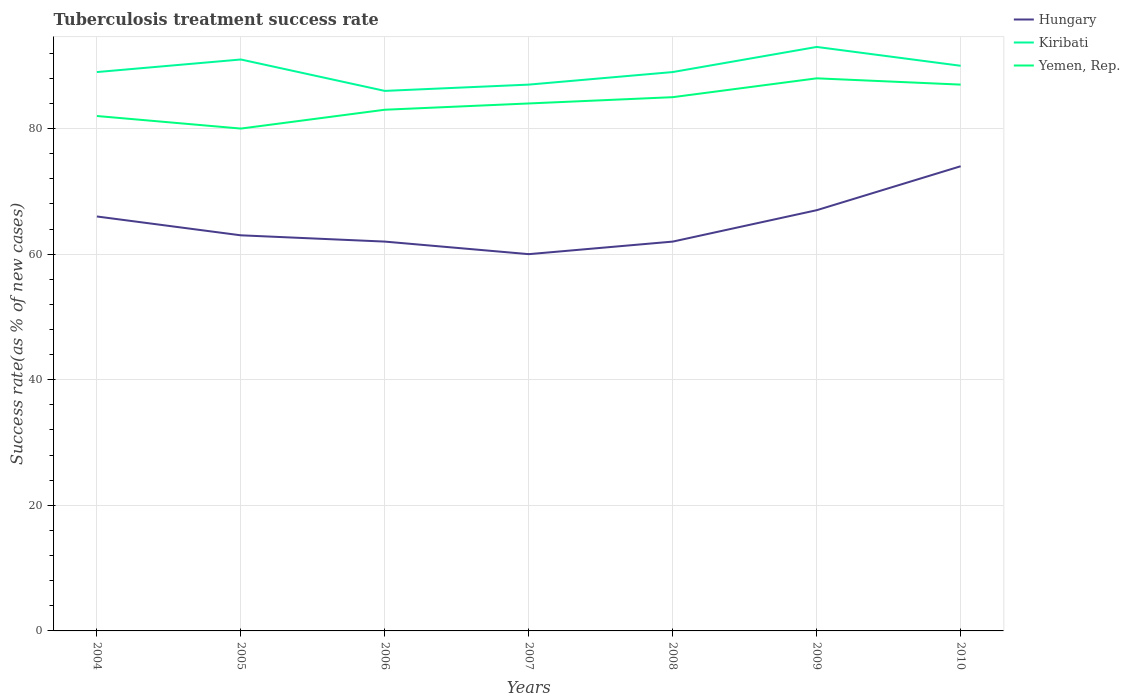How many different coloured lines are there?
Offer a terse response. 3. Across all years, what is the maximum tuberculosis treatment success rate in Yemen, Rep.?
Keep it short and to the point. 80. What is the total tuberculosis treatment success rate in Hungary in the graph?
Your answer should be compact. 4. What is the difference between the highest and the second highest tuberculosis treatment success rate in Kiribati?
Offer a terse response. 7. What is the difference between the highest and the lowest tuberculosis treatment success rate in Hungary?
Provide a succinct answer. 3. How many lines are there?
Keep it short and to the point. 3. How many years are there in the graph?
Offer a terse response. 7. Are the values on the major ticks of Y-axis written in scientific E-notation?
Ensure brevity in your answer.  No. Does the graph contain grids?
Provide a succinct answer. Yes. How are the legend labels stacked?
Offer a very short reply. Vertical. What is the title of the graph?
Your response must be concise. Tuberculosis treatment success rate. What is the label or title of the Y-axis?
Offer a very short reply. Success rate(as % of new cases). What is the Success rate(as % of new cases) of Kiribati in 2004?
Offer a terse response. 89. What is the Success rate(as % of new cases) in Hungary in 2005?
Your answer should be very brief. 63. What is the Success rate(as % of new cases) of Kiribati in 2005?
Provide a succinct answer. 91. What is the Success rate(as % of new cases) in Kiribati in 2006?
Your response must be concise. 86. What is the Success rate(as % of new cases) of Kiribati in 2007?
Offer a very short reply. 87. What is the Success rate(as % of new cases) in Yemen, Rep. in 2007?
Your answer should be very brief. 84. What is the Success rate(as % of new cases) of Kiribati in 2008?
Ensure brevity in your answer.  89. What is the Success rate(as % of new cases) in Kiribati in 2009?
Provide a short and direct response. 93. What is the Success rate(as % of new cases) of Hungary in 2010?
Make the answer very short. 74. What is the Success rate(as % of new cases) in Kiribati in 2010?
Your answer should be very brief. 90. What is the Success rate(as % of new cases) of Yemen, Rep. in 2010?
Provide a short and direct response. 87. Across all years, what is the maximum Success rate(as % of new cases) in Hungary?
Provide a succinct answer. 74. Across all years, what is the maximum Success rate(as % of new cases) in Kiribati?
Your response must be concise. 93. Across all years, what is the minimum Success rate(as % of new cases) in Hungary?
Offer a terse response. 60. What is the total Success rate(as % of new cases) in Hungary in the graph?
Your answer should be compact. 454. What is the total Success rate(as % of new cases) of Kiribati in the graph?
Provide a succinct answer. 625. What is the total Success rate(as % of new cases) of Yemen, Rep. in the graph?
Provide a succinct answer. 589. What is the difference between the Success rate(as % of new cases) in Kiribati in 2004 and that in 2005?
Give a very brief answer. -2. What is the difference between the Success rate(as % of new cases) in Yemen, Rep. in 2004 and that in 2005?
Make the answer very short. 2. What is the difference between the Success rate(as % of new cases) of Kiribati in 2004 and that in 2006?
Provide a succinct answer. 3. What is the difference between the Success rate(as % of new cases) in Hungary in 2004 and that in 2007?
Your answer should be very brief. 6. What is the difference between the Success rate(as % of new cases) of Kiribati in 2004 and that in 2007?
Provide a succinct answer. 2. What is the difference between the Success rate(as % of new cases) in Yemen, Rep. in 2004 and that in 2007?
Offer a very short reply. -2. What is the difference between the Success rate(as % of new cases) of Hungary in 2004 and that in 2009?
Provide a short and direct response. -1. What is the difference between the Success rate(as % of new cases) in Hungary in 2004 and that in 2010?
Your response must be concise. -8. What is the difference between the Success rate(as % of new cases) in Yemen, Rep. in 2004 and that in 2010?
Your answer should be very brief. -5. What is the difference between the Success rate(as % of new cases) of Kiribati in 2005 and that in 2006?
Offer a very short reply. 5. What is the difference between the Success rate(as % of new cases) of Yemen, Rep. in 2005 and that in 2006?
Provide a succinct answer. -3. What is the difference between the Success rate(as % of new cases) in Kiribati in 2005 and that in 2007?
Your answer should be compact. 4. What is the difference between the Success rate(as % of new cases) of Yemen, Rep. in 2005 and that in 2007?
Give a very brief answer. -4. What is the difference between the Success rate(as % of new cases) of Hungary in 2005 and that in 2008?
Offer a terse response. 1. What is the difference between the Success rate(as % of new cases) of Kiribati in 2005 and that in 2008?
Offer a terse response. 2. What is the difference between the Success rate(as % of new cases) in Kiribati in 2005 and that in 2009?
Your answer should be very brief. -2. What is the difference between the Success rate(as % of new cases) of Yemen, Rep. in 2005 and that in 2009?
Keep it short and to the point. -8. What is the difference between the Success rate(as % of new cases) of Kiribati in 2005 and that in 2010?
Your answer should be very brief. 1. What is the difference between the Success rate(as % of new cases) in Yemen, Rep. in 2005 and that in 2010?
Offer a terse response. -7. What is the difference between the Success rate(as % of new cases) of Hungary in 2006 and that in 2007?
Your answer should be very brief. 2. What is the difference between the Success rate(as % of new cases) in Kiribati in 2006 and that in 2007?
Offer a terse response. -1. What is the difference between the Success rate(as % of new cases) of Hungary in 2006 and that in 2008?
Offer a very short reply. 0. What is the difference between the Success rate(as % of new cases) of Kiribati in 2006 and that in 2008?
Offer a very short reply. -3. What is the difference between the Success rate(as % of new cases) of Hungary in 2006 and that in 2009?
Provide a short and direct response. -5. What is the difference between the Success rate(as % of new cases) in Kiribati in 2006 and that in 2009?
Your answer should be compact. -7. What is the difference between the Success rate(as % of new cases) in Yemen, Rep. in 2006 and that in 2010?
Make the answer very short. -4. What is the difference between the Success rate(as % of new cases) in Hungary in 2007 and that in 2008?
Your response must be concise. -2. What is the difference between the Success rate(as % of new cases) in Kiribati in 2007 and that in 2008?
Make the answer very short. -2. What is the difference between the Success rate(as % of new cases) in Yemen, Rep. in 2007 and that in 2008?
Offer a terse response. -1. What is the difference between the Success rate(as % of new cases) in Hungary in 2008 and that in 2010?
Keep it short and to the point. -12. What is the difference between the Success rate(as % of new cases) of Kiribati in 2009 and that in 2010?
Your response must be concise. 3. What is the difference between the Success rate(as % of new cases) of Yemen, Rep. in 2009 and that in 2010?
Provide a succinct answer. 1. What is the difference between the Success rate(as % of new cases) of Hungary in 2004 and the Success rate(as % of new cases) of Kiribati in 2005?
Give a very brief answer. -25. What is the difference between the Success rate(as % of new cases) in Kiribati in 2004 and the Success rate(as % of new cases) in Yemen, Rep. in 2005?
Make the answer very short. 9. What is the difference between the Success rate(as % of new cases) of Hungary in 2004 and the Success rate(as % of new cases) of Yemen, Rep. in 2006?
Your answer should be very brief. -17. What is the difference between the Success rate(as % of new cases) in Hungary in 2004 and the Success rate(as % of new cases) in Kiribati in 2007?
Your response must be concise. -21. What is the difference between the Success rate(as % of new cases) of Kiribati in 2004 and the Success rate(as % of new cases) of Yemen, Rep. in 2007?
Offer a terse response. 5. What is the difference between the Success rate(as % of new cases) in Hungary in 2004 and the Success rate(as % of new cases) in Kiribati in 2009?
Make the answer very short. -27. What is the difference between the Success rate(as % of new cases) of Hungary in 2004 and the Success rate(as % of new cases) of Yemen, Rep. in 2009?
Give a very brief answer. -22. What is the difference between the Success rate(as % of new cases) of Kiribati in 2004 and the Success rate(as % of new cases) of Yemen, Rep. in 2009?
Your answer should be very brief. 1. What is the difference between the Success rate(as % of new cases) in Hungary in 2004 and the Success rate(as % of new cases) in Kiribati in 2010?
Your answer should be compact. -24. What is the difference between the Success rate(as % of new cases) of Hungary in 2004 and the Success rate(as % of new cases) of Yemen, Rep. in 2010?
Make the answer very short. -21. What is the difference between the Success rate(as % of new cases) in Hungary in 2005 and the Success rate(as % of new cases) in Kiribati in 2007?
Keep it short and to the point. -24. What is the difference between the Success rate(as % of new cases) in Hungary in 2005 and the Success rate(as % of new cases) in Yemen, Rep. in 2007?
Your response must be concise. -21. What is the difference between the Success rate(as % of new cases) of Kiribati in 2005 and the Success rate(as % of new cases) of Yemen, Rep. in 2007?
Your answer should be very brief. 7. What is the difference between the Success rate(as % of new cases) of Hungary in 2005 and the Success rate(as % of new cases) of Kiribati in 2008?
Keep it short and to the point. -26. What is the difference between the Success rate(as % of new cases) in Hungary in 2005 and the Success rate(as % of new cases) in Yemen, Rep. in 2008?
Your answer should be compact. -22. What is the difference between the Success rate(as % of new cases) of Kiribati in 2005 and the Success rate(as % of new cases) of Yemen, Rep. in 2009?
Give a very brief answer. 3. What is the difference between the Success rate(as % of new cases) of Hungary in 2005 and the Success rate(as % of new cases) of Yemen, Rep. in 2010?
Your answer should be very brief. -24. What is the difference between the Success rate(as % of new cases) in Kiribati in 2005 and the Success rate(as % of new cases) in Yemen, Rep. in 2010?
Your response must be concise. 4. What is the difference between the Success rate(as % of new cases) of Hungary in 2006 and the Success rate(as % of new cases) of Kiribati in 2007?
Keep it short and to the point. -25. What is the difference between the Success rate(as % of new cases) in Hungary in 2006 and the Success rate(as % of new cases) in Yemen, Rep. in 2007?
Provide a short and direct response. -22. What is the difference between the Success rate(as % of new cases) of Hungary in 2006 and the Success rate(as % of new cases) of Kiribati in 2008?
Ensure brevity in your answer.  -27. What is the difference between the Success rate(as % of new cases) of Hungary in 2006 and the Success rate(as % of new cases) of Yemen, Rep. in 2008?
Offer a terse response. -23. What is the difference between the Success rate(as % of new cases) in Hungary in 2006 and the Success rate(as % of new cases) in Kiribati in 2009?
Offer a terse response. -31. What is the difference between the Success rate(as % of new cases) of Kiribati in 2006 and the Success rate(as % of new cases) of Yemen, Rep. in 2009?
Your answer should be compact. -2. What is the difference between the Success rate(as % of new cases) in Hungary in 2006 and the Success rate(as % of new cases) in Kiribati in 2010?
Provide a succinct answer. -28. What is the difference between the Success rate(as % of new cases) of Kiribati in 2007 and the Success rate(as % of new cases) of Yemen, Rep. in 2008?
Make the answer very short. 2. What is the difference between the Success rate(as % of new cases) in Hungary in 2007 and the Success rate(as % of new cases) in Kiribati in 2009?
Offer a terse response. -33. What is the difference between the Success rate(as % of new cases) of Hungary in 2007 and the Success rate(as % of new cases) of Yemen, Rep. in 2010?
Give a very brief answer. -27. What is the difference between the Success rate(as % of new cases) of Hungary in 2008 and the Success rate(as % of new cases) of Kiribati in 2009?
Give a very brief answer. -31. What is the difference between the Success rate(as % of new cases) in Hungary in 2008 and the Success rate(as % of new cases) in Yemen, Rep. in 2010?
Your response must be concise. -25. What is the difference between the Success rate(as % of new cases) of Kiribati in 2008 and the Success rate(as % of new cases) of Yemen, Rep. in 2010?
Your answer should be compact. 2. What is the difference between the Success rate(as % of new cases) of Hungary in 2009 and the Success rate(as % of new cases) of Yemen, Rep. in 2010?
Offer a terse response. -20. What is the difference between the Success rate(as % of new cases) of Kiribati in 2009 and the Success rate(as % of new cases) of Yemen, Rep. in 2010?
Provide a short and direct response. 6. What is the average Success rate(as % of new cases) of Hungary per year?
Your response must be concise. 64.86. What is the average Success rate(as % of new cases) in Kiribati per year?
Your response must be concise. 89.29. What is the average Success rate(as % of new cases) in Yemen, Rep. per year?
Make the answer very short. 84.14. In the year 2004, what is the difference between the Success rate(as % of new cases) in Hungary and Success rate(as % of new cases) in Kiribati?
Your answer should be compact. -23. In the year 2004, what is the difference between the Success rate(as % of new cases) in Kiribati and Success rate(as % of new cases) in Yemen, Rep.?
Ensure brevity in your answer.  7. In the year 2005, what is the difference between the Success rate(as % of new cases) in Hungary and Success rate(as % of new cases) in Kiribati?
Make the answer very short. -28. In the year 2005, what is the difference between the Success rate(as % of new cases) in Hungary and Success rate(as % of new cases) in Yemen, Rep.?
Provide a short and direct response. -17. In the year 2006, what is the difference between the Success rate(as % of new cases) in Hungary and Success rate(as % of new cases) in Kiribati?
Provide a succinct answer. -24. In the year 2006, what is the difference between the Success rate(as % of new cases) of Kiribati and Success rate(as % of new cases) of Yemen, Rep.?
Your response must be concise. 3. In the year 2007, what is the difference between the Success rate(as % of new cases) in Hungary and Success rate(as % of new cases) in Kiribati?
Offer a very short reply. -27. In the year 2007, what is the difference between the Success rate(as % of new cases) of Hungary and Success rate(as % of new cases) of Yemen, Rep.?
Your answer should be compact. -24. In the year 2009, what is the difference between the Success rate(as % of new cases) of Hungary and Success rate(as % of new cases) of Kiribati?
Offer a terse response. -26. In the year 2010, what is the difference between the Success rate(as % of new cases) in Hungary and Success rate(as % of new cases) in Kiribati?
Your answer should be compact. -16. In the year 2010, what is the difference between the Success rate(as % of new cases) of Hungary and Success rate(as % of new cases) of Yemen, Rep.?
Offer a terse response. -13. What is the ratio of the Success rate(as % of new cases) of Hungary in 2004 to that in 2005?
Your answer should be very brief. 1.05. What is the ratio of the Success rate(as % of new cases) in Hungary in 2004 to that in 2006?
Offer a very short reply. 1.06. What is the ratio of the Success rate(as % of new cases) in Kiribati in 2004 to that in 2006?
Keep it short and to the point. 1.03. What is the ratio of the Success rate(as % of new cases) in Yemen, Rep. in 2004 to that in 2006?
Your answer should be compact. 0.99. What is the ratio of the Success rate(as % of new cases) in Yemen, Rep. in 2004 to that in 2007?
Keep it short and to the point. 0.98. What is the ratio of the Success rate(as % of new cases) in Hungary in 2004 to that in 2008?
Offer a very short reply. 1.06. What is the ratio of the Success rate(as % of new cases) in Yemen, Rep. in 2004 to that in 2008?
Your answer should be very brief. 0.96. What is the ratio of the Success rate(as % of new cases) in Hungary in 2004 to that in 2009?
Your answer should be very brief. 0.99. What is the ratio of the Success rate(as % of new cases) in Kiribati in 2004 to that in 2009?
Offer a very short reply. 0.96. What is the ratio of the Success rate(as % of new cases) of Yemen, Rep. in 2004 to that in 2009?
Give a very brief answer. 0.93. What is the ratio of the Success rate(as % of new cases) in Hungary in 2004 to that in 2010?
Make the answer very short. 0.89. What is the ratio of the Success rate(as % of new cases) of Kiribati in 2004 to that in 2010?
Ensure brevity in your answer.  0.99. What is the ratio of the Success rate(as % of new cases) in Yemen, Rep. in 2004 to that in 2010?
Your answer should be very brief. 0.94. What is the ratio of the Success rate(as % of new cases) in Hungary in 2005 to that in 2006?
Your answer should be compact. 1.02. What is the ratio of the Success rate(as % of new cases) of Kiribati in 2005 to that in 2006?
Your answer should be very brief. 1.06. What is the ratio of the Success rate(as % of new cases) in Yemen, Rep. in 2005 to that in 2006?
Offer a terse response. 0.96. What is the ratio of the Success rate(as % of new cases) in Kiribati in 2005 to that in 2007?
Your response must be concise. 1.05. What is the ratio of the Success rate(as % of new cases) in Hungary in 2005 to that in 2008?
Your answer should be compact. 1.02. What is the ratio of the Success rate(as % of new cases) of Kiribati in 2005 to that in 2008?
Provide a succinct answer. 1.02. What is the ratio of the Success rate(as % of new cases) of Hungary in 2005 to that in 2009?
Offer a very short reply. 0.94. What is the ratio of the Success rate(as % of new cases) of Kiribati in 2005 to that in 2009?
Make the answer very short. 0.98. What is the ratio of the Success rate(as % of new cases) in Hungary in 2005 to that in 2010?
Provide a succinct answer. 0.85. What is the ratio of the Success rate(as % of new cases) of Kiribati in 2005 to that in 2010?
Make the answer very short. 1.01. What is the ratio of the Success rate(as % of new cases) of Yemen, Rep. in 2005 to that in 2010?
Offer a very short reply. 0.92. What is the ratio of the Success rate(as % of new cases) of Hungary in 2006 to that in 2008?
Your response must be concise. 1. What is the ratio of the Success rate(as % of new cases) of Kiribati in 2006 to that in 2008?
Make the answer very short. 0.97. What is the ratio of the Success rate(as % of new cases) of Yemen, Rep. in 2006 to that in 2008?
Offer a very short reply. 0.98. What is the ratio of the Success rate(as % of new cases) in Hungary in 2006 to that in 2009?
Give a very brief answer. 0.93. What is the ratio of the Success rate(as % of new cases) in Kiribati in 2006 to that in 2009?
Make the answer very short. 0.92. What is the ratio of the Success rate(as % of new cases) in Yemen, Rep. in 2006 to that in 2009?
Ensure brevity in your answer.  0.94. What is the ratio of the Success rate(as % of new cases) in Hungary in 2006 to that in 2010?
Make the answer very short. 0.84. What is the ratio of the Success rate(as % of new cases) of Kiribati in 2006 to that in 2010?
Your response must be concise. 0.96. What is the ratio of the Success rate(as % of new cases) in Yemen, Rep. in 2006 to that in 2010?
Your response must be concise. 0.95. What is the ratio of the Success rate(as % of new cases) of Hungary in 2007 to that in 2008?
Your answer should be very brief. 0.97. What is the ratio of the Success rate(as % of new cases) in Kiribati in 2007 to that in 2008?
Ensure brevity in your answer.  0.98. What is the ratio of the Success rate(as % of new cases) in Yemen, Rep. in 2007 to that in 2008?
Keep it short and to the point. 0.99. What is the ratio of the Success rate(as % of new cases) of Hungary in 2007 to that in 2009?
Make the answer very short. 0.9. What is the ratio of the Success rate(as % of new cases) in Kiribati in 2007 to that in 2009?
Ensure brevity in your answer.  0.94. What is the ratio of the Success rate(as % of new cases) of Yemen, Rep. in 2007 to that in 2009?
Offer a terse response. 0.95. What is the ratio of the Success rate(as % of new cases) of Hungary in 2007 to that in 2010?
Ensure brevity in your answer.  0.81. What is the ratio of the Success rate(as % of new cases) in Kiribati in 2007 to that in 2010?
Your answer should be very brief. 0.97. What is the ratio of the Success rate(as % of new cases) of Yemen, Rep. in 2007 to that in 2010?
Keep it short and to the point. 0.97. What is the ratio of the Success rate(as % of new cases) in Hungary in 2008 to that in 2009?
Keep it short and to the point. 0.93. What is the ratio of the Success rate(as % of new cases) in Kiribati in 2008 to that in 2009?
Make the answer very short. 0.96. What is the ratio of the Success rate(as % of new cases) in Yemen, Rep. in 2008 to that in 2009?
Keep it short and to the point. 0.97. What is the ratio of the Success rate(as % of new cases) in Hungary in 2008 to that in 2010?
Your answer should be very brief. 0.84. What is the ratio of the Success rate(as % of new cases) of Kiribati in 2008 to that in 2010?
Make the answer very short. 0.99. What is the ratio of the Success rate(as % of new cases) of Hungary in 2009 to that in 2010?
Keep it short and to the point. 0.91. What is the ratio of the Success rate(as % of new cases) in Kiribati in 2009 to that in 2010?
Make the answer very short. 1.03. What is the ratio of the Success rate(as % of new cases) in Yemen, Rep. in 2009 to that in 2010?
Offer a very short reply. 1.01. What is the difference between the highest and the second highest Success rate(as % of new cases) in Hungary?
Provide a succinct answer. 7. What is the difference between the highest and the second highest Success rate(as % of new cases) of Kiribati?
Your response must be concise. 2. What is the difference between the highest and the second highest Success rate(as % of new cases) in Yemen, Rep.?
Ensure brevity in your answer.  1. 